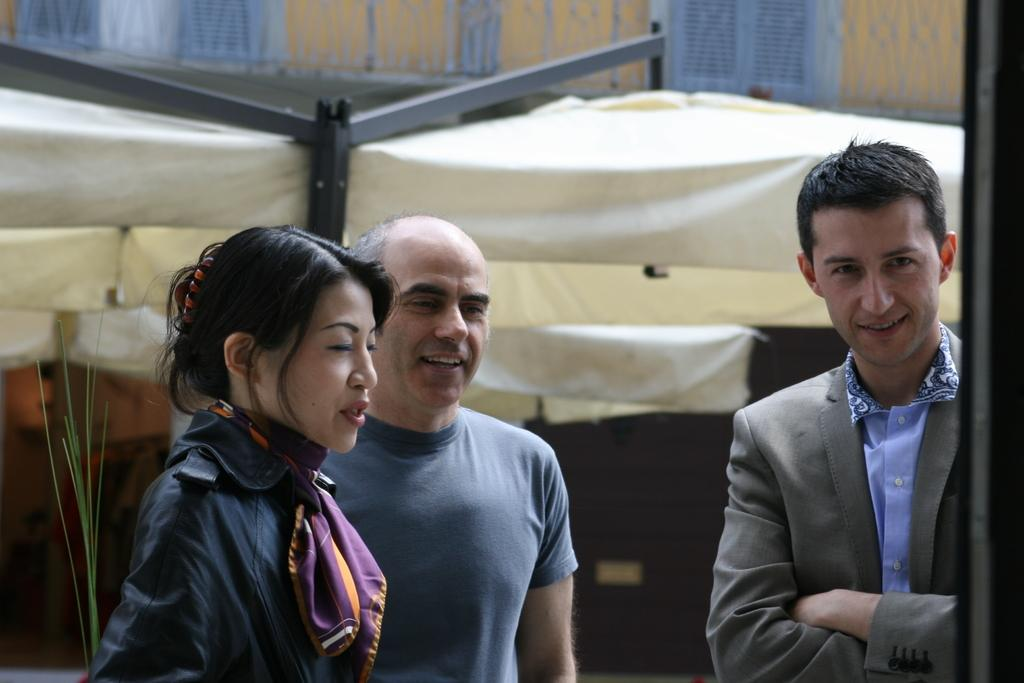How many people are in the image? There are three persons in the image. What structure can be seen in the image? There is a canopy tent in the image. Can you describe the background of the image? The background of the image is blurred. What type of paste is being used by the persons in the image? There is no paste visible in the image, and the persons are not shown using any paste. 